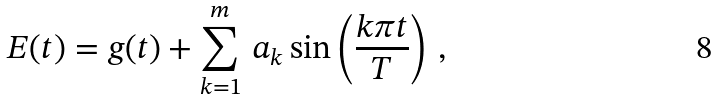Convert formula to latex. <formula><loc_0><loc_0><loc_500><loc_500>E ( t ) = g ( t ) + \sum _ { k = 1 } ^ { m } \, a _ { k } \sin \left ( \frac { k \pi t } { T } \right ) \, ,</formula> 